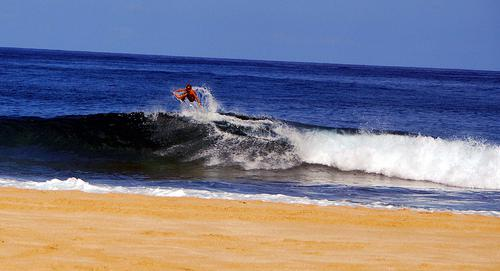Question: what is the photo showing?
Choices:
A. A deer.
B. Someone surfing.
C. A cow.
D. A dog.
Answer with the letter. Answer: B Question: what color is the sand?
Choices:
A. White.
B. Tan.
C. Light brown.
D. Black.
Answer with the letter. Answer: C Question: who is surfing?
Choices:
A. A man.
B. The person.
C. A woman.
D. A girl.
Answer with the letter. Answer: B Question: how many people are in the picture?
Choices:
A. 13.
B. 5.
C. One person.
D. 7.
Answer with the letter. Answer: C Question: what is the color of the sky?
Choices:
A. Blue.
B. Green.
C. White.
D. Yellow.
Answer with the letter. Answer: A Question: where was this taken?
Choices:
A. On the train.
B. A cruise.
C. On the beach.
D. On the bus.
Answer with the letter. Answer: C 